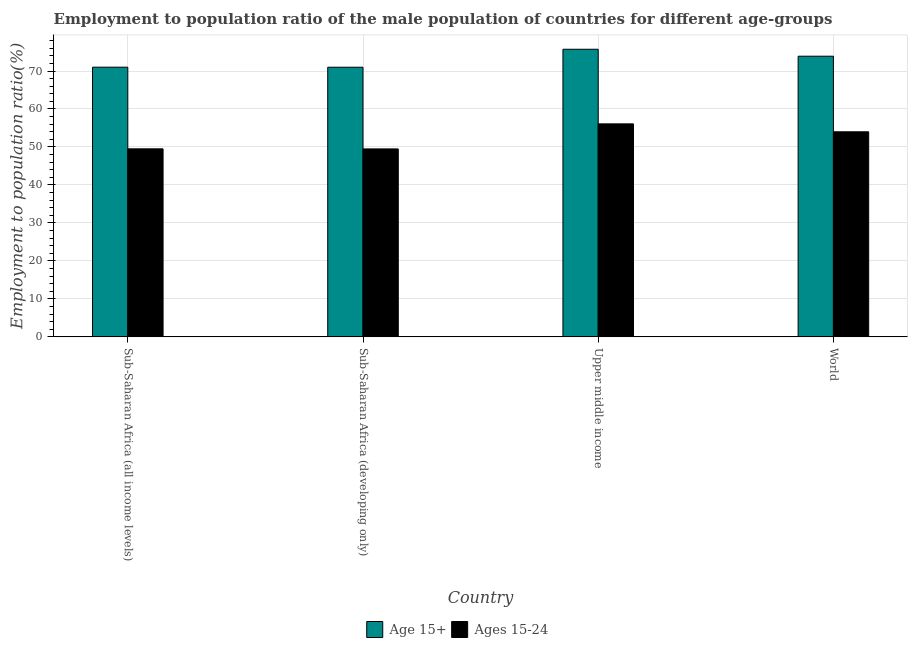What is the label of the 4th group of bars from the left?
Give a very brief answer. World. What is the employment to population ratio(age 15+) in Sub-Saharan Africa (all income levels)?
Your response must be concise. 71.01. Across all countries, what is the maximum employment to population ratio(age 15+)?
Give a very brief answer. 75.73. Across all countries, what is the minimum employment to population ratio(age 15-24)?
Offer a terse response. 49.49. In which country was the employment to population ratio(age 15+) maximum?
Offer a very short reply. Upper middle income. In which country was the employment to population ratio(age 15-24) minimum?
Your answer should be very brief. Sub-Saharan Africa (developing only). What is the total employment to population ratio(age 15+) in the graph?
Provide a succinct answer. 291.62. What is the difference between the employment to population ratio(age 15+) in Upper middle income and that in World?
Keep it short and to the point. 1.83. What is the difference between the employment to population ratio(age 15-24) in Sub-Saharan Africa (developing only) and the employment to population ratio(age 15+) in World?
Your answer should be compact. -24.41. What is the average employment to population ratio(age 15-24) per country?
Provide a short and direct response. 52.27. What is the difference between the employment to population ratio(age 15-24) and employment to population ratio(age 15+) in Sub-Saharan Africa (all income levels)?
Your response must be concise. -21.5. What is the ratio of the employment to population ratio(age 15+) in Sub-Saharan Africa (developing only) to that in Upper middle income?
Ensure brevity in your answer.  0.94. What is the difference between the highest and the second highest employment to population ratio(age 15+)?
Your answer should be compact. 1.83. What is the difference between the highest and the lowest employment to population ratio(age 15+)?
Your answer should be very brief. 4.73. In how many countries, is the employment to population ratio(age 15+) greater than the average employment to population ratio(age 15+) taken over all countries?
Provide a succinct answer. 2. What does the 2nd bar from the left in World represents?
Make the answer very short. Ages 15-24. What does the 1st bar from the right in World represents?
Ensure brevity in your answer.  Ages 15-24. How many countries are there in the graph?
Provide a succinct answer. 4. What is the difference between two consecutive major ticks on the Y-axis?
Offer a terse response. 10. Where does the legend appear in the graph?
Your answer should be compact. Bottom center. How are the legend labels stacked?
Your response must be concise. Horizontal. What is the title of the graph?
Offer a very short reply. Employment to population ratio of the male population of countries for different age-groups. What is the label or title of the X-axis?
Your response must be concise. Country. What is the label or title of the Y-axis?
Provide a succinct answer. Employment to population ratio(%). What is the Employment to population ratio(%) of Age 15+ in Sub-Saharan Africa (all income levels)?
Make the answer very short. 71.01. What is the Employment to population ratio(%) of Ages 15-24 in Sub-Saharan Africa (all income levels)?
Your answer should be compact. 49.51. What is the Employment to population ratio(%) in Age 15+ in Sub-Saharan Africa (developing only)?
Your answer should be compact. 70.99. What is the Employment to population ratio(%) in Ages 15-24 in Sub-Saharan Africa (developing only)?
Give a very brief answer. 49.49. What is the Employment to population ratio(%) in Age 15+ in Upper middle income?
Offer a terse response. 75.73. What is the Employment to population ratio(%) in Ages 15-24 in Upper middle income?
Your response must be concise. 56.08. What is the Employment to population ratio(%) of Age 15+ in World?
Your response must be concise. 73.89. What is the Employment to population ratio(%) of Ages 15-24 in World?
Keep it short and to the point. 53.99. Across all countries, what is the maximum Employment to population ratio(%) of Age 15+?
Provide a succinct answer. 75.73. Across all countries, what is the maximum Employment to population ratio(%) in Ages 15-24?
Give a very brief answer. 56.08. Across all countries, what is the minimum Employment to population ratio(%) of Age 15+?
Provide a short and direct response. 70.99. Across all countries, what is the minimum Employment to population ratio(%) of Ages 15-24?
Your answer should be very brief. 49.49. What is the total Employment to population ratio(%) in Age 15+ in the graph?
Offer a terse response. 291.62. What is the total Employment to population ratio(%) in Ages 15-24 in the graph?
Your answer should be compact. 209.07. What is the difference between the Employment to population ratio(%) in Age 15+ in Sub-Saharan Africa (all income levels) and that in Sub-Saharan Africa (developing only)?
Keep it short and to the point. 0.01. What is the difference between the Employment to population ratio(%) in Ages 15-24 in Sub-Saharan Africa (all income levels) and that in Sub-Saharan Africa (developing only)?
Give a very brief answer. 0.02. What is the difference between the Employment to population ratio(%) of Age 15+ in Sub-Saharan Africa (all income levels) and that in Upper middle income?
Make the answer very short. -4.72. What is the difference between the Employment to population ratio(%) in Ages 15-24 in Sub-Saharan Africa (all income levels) and that in Upper middle income?
Keep it short and to the point. -6.58. What is the difference between the Employment to population ratio(%) of Age 15+ in Sub-Saharan Africa (all income levels) and that in World?
Your answer should be compact. -2.89. What is the difference between the Employment to population ratio(%) in Ages 15-24 in Sub-Saharan Africa (all income levels) and that in World?
Your answer should be compact. -4.49. What is the difference between the Employment to population ratio(%) of Age 15+ in Sub-Saharan Africa (developing only) and that in Upper middle income?
Ensure brevity in your answer.  -4.73. What is the difference between the Employment to population ratio(%) of Ages 15-24 in Sub-Saharan Africa (developing only) and that in Upper middle income?
Provide a short and direct response. -6.59. What is the difference between the Employment to population ratio(%) in Age 15+ in Sub-Saharan Africa (developing only) and that in World?
Your answer should be very brief. -2.9. What is the difference between the Employment to population ratio(%) of Ages 15-24 in Sub-Saharan Africa (developing only) and that in World?
Make the answer very short. -4.5. What is the difference between the Employment to population ratio(%) in Age 15+ in Upper middle income and that in World?
Ensure brevity in your answer.  1.83. What is the difference between the Employment to population ratio(%) of Ages 15-24 in Upper middle income and that in World?
Make the answer very short. 2.09. What is the difference between the Employment to population ratio(%) in Age 15+ in Sub-Saharan Africa (all income levels) and the Employment to population ratio(%) in Ages 15-24 in Sub-Saharan Africa (developing only)?
Your answer should be very brief. 21.52. What is the difference between the Employment to population ratio(%) of Age 15+ in Sub-Saharan Africa (all income levels) and the Employment to population ratio(%) of Ages 15-24 in Upper middle income?
Provide a succinct answer. 14.93. What is the difference between the Employment to population ratio(%) in Age 15+ in Sub-Saharan Africa (all income levels) and the Employment to population ratio(%) in Ages 15-24 in World?
Your answer should be very brief. 17.01. What is the difference between the Employment to population ratio(%) in Age 15+ in Sub-Saharan Africa (developing only) and the Employment to population ratio(%) in Ages 15-24 in Upper middle income?
Offer a very short reply. 14.91. What is the difference between the Employment to population ratio(%) in Age 15+ in Sub-Saharan Africa (developing only) and the Employment to population ratio(%) in Ages 15-24 in World?
Your answer should be very brief. 17. What is the difference between the Employment to population ratio(%) of Age 15+ in Upper middle income and the Employment to population ratio(%) of Ages 15-24 in World?
Give a very brief answer. 21.73. What is the average Employment to population ratio(%) in Age 15+ per country?
Your response must be concise. 72.9. What is the average Employment to population ratio(%) of Ages 15-24 per country?
Offer a very short reply. 52.27. What is the difference between the Employment to population ratio(%) in Age 15+ and Employment to population ratio(%) in Ages 15-24 in Sub-Saharan Africa (all income levels)?
Offer a terse response. 21.5. What is the difference between the Employment to population ratio(%) of Age 15+ and Employment to population ratio(%) of Ages 15-24 in Sub-Saharan Africa (developing only)?
Provide a succinct answer. 21.5. What is the difference between the Employment to population ratio(%) of Age 15+ and Employment to population ratio(%) of Ages 15-24 in Upper middle income?
Give a very brief answer. 19.64. What is the difference between the Employment to population ratio(%) in Age 15+ and Employment to population ratio(%) in Ages 15-24 in World?
Ensure brevity in your answer.  19.9. What is the ratio of the Employment to population ratio(%) of Age 15+ in Sub-Saharan Africa (all income levels) to that in Upper middle income?
Offer a very short reply. 0.94. What is the ratio of the Employment to population ratio(%) of Ages 15-24 in Sub-Saharan Africa (all income levels) to that in Upper middle income?
Your answer should be very brief. 0.88. What is the ratio of the Employment to population ratio(%) in Age 15+ in Sub-Saharan Africa (all income levels) to that in World?
Keep it short and to the point. 0.96. What is the ratio of the Employment to population ratio(%) of Ages 15-24 in Sub-Saharan Africa (all income levels) to that in World?
Provide a short and direct response. 0.92. What is the ratio of the Employment to population ratio(%) of Age 15+ in Sub-Saharan Africa (developing only) to that in Upper middle income?
Keep it short and to the point. 0.94. What is the ratio of the Employment to population ratio(%) of Ages 15-24 in Sub-Saharan Africa (developing only) to that in Upper middle income?
Provide a succinct answer. 0.88. What is the ratio of the Employment to population ratio(%) in Age 15+ in Sub-Saharan Africa (developing only) to that in World?
Provide a short and direct response. 0.96. What is the ratio of the Employment to population ratio(%) of Ages 15-24 in Sub-Saharan Africa (developing only) to that in World?
Your response must be concise. 0.92. What is the ratio of the Employment to population ratio(%) of Age 15+ in Upper middle income to that in World?
Give a very brief answer. 1.02. What is the ratio of the Employment to population ratio(%) of Ages 15-24 in Upper middle income to that in World?
Offer a terse response. 1.04. What is the difference between the highest and the second highest Employment to population ratio(%) in Age 15+?
Your answer should be compact. 1.83. What is the difference between the highest and the second highest Employment to population ratio(%) in Ages 15-24?
Offer a terse response. 2.09. What is the difference between the highest and the lowest Employment to population ratio(%) in Age 15+?
Offer a very short reply. 4.73. What is the difference between the highest and the lowest Employment to population ratio(%) of Ages 15-24?
Ensure brevity in your answer.  6.59. 